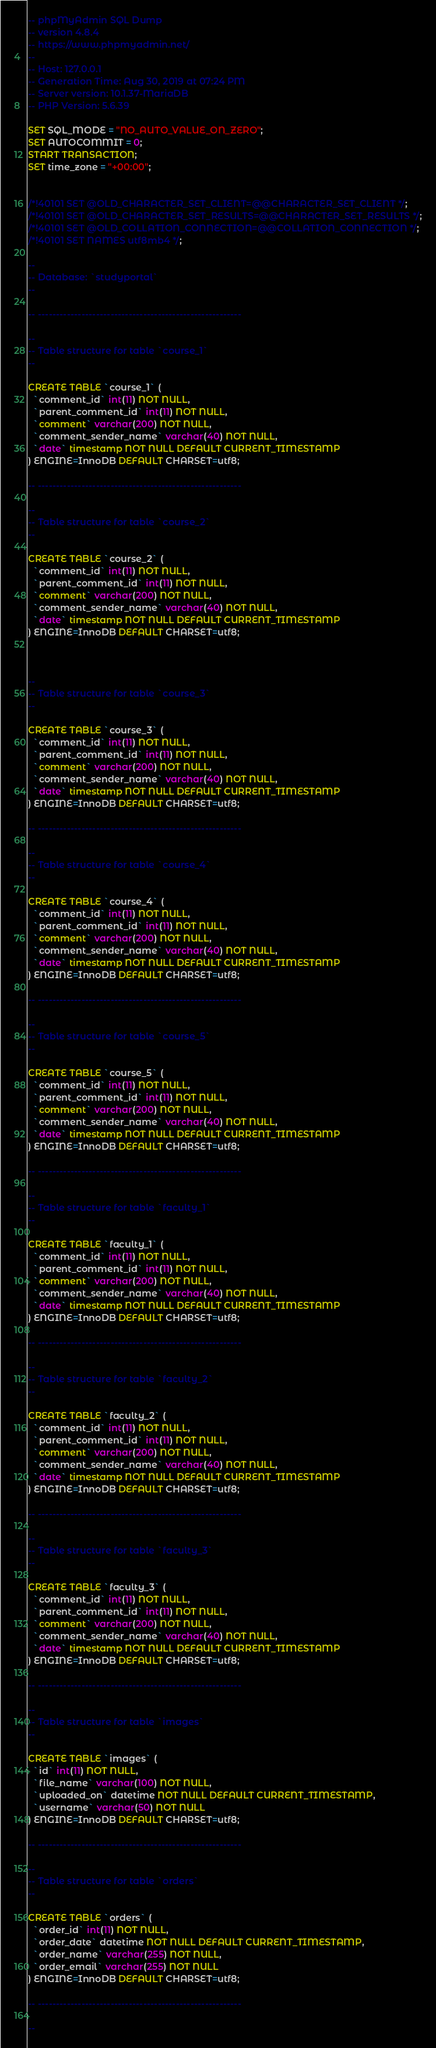Convert code to text. <code><loc_0><loc_0><loc_500><loc_500><_SQL_>-- phpMyAdmin SQL Dump
-- version 4.8.4
-- https://www.phpmyadmin.net/
--
-- Host: 127.0.0.1
-- Generation Time: Aug 30, 2019 at 07:24 PM
-- Server version: 10.1.37-MariaDB
-- PHP Version: 5.6.39

SET SQL_MODE = "NO_AUTO_VALUE_ON_ZERO";
SET AUTOCOMMIT = 0;
START TRANSACTION;
SET time_zone = "+00:00";


/*!40101 SET @OLD_CHARACTER_SET_CLIENT=@@CHARACTER_SET_CLIENT */;
/*!40101 SET @OLD_CHARACTER_SET_RESULTS=@@CHARACTER_SET_RESULTS */;
/*!40101 SET @OLD_COLLATION_CONNECTION=@@COLLATION_CONNECTION */;
/*!40101 SET NAMES utf8mb4 */;

--
-- Database: `studyportal`
--

-- --------------------------------------------------------

--
-- Table structure for table `course_1`
--

CREATE TABLE `course_1` (
  `comment_id` int(11) NOT NULL,
  `parent_comment_id` int(11) NOT NULL,
  `comment` varchar(200) NOT NULL,
  `comment_sender_name` varchar(40) NOT NULL,
  `date` timestamp NOT NULL DEFAULT CURRENT_TIMESTAMP
) ENGINE=InnoDB DEFAULT CHARSET=utf8;

-- --------------------------------------------------------

--
-- Table structure for table `course_2`
--

CREATE TABLE `course_2` (
  `comment_id` int(11) NOT NULL,
  `parent_comment_id` int(11) NOT NULL,
  `comment` varchar(200) NOT NULL,
  `comment_sender_name` varchar(40) NOT NULL,
  `date` timestamp NOT NULL DEFAULT CURRENT_TIMESTAMP
) ENGINE=InnoDB DEFAULT CHARSET=utf8;



--
-- Table structure for table `course_3`
--

CREATE TABLE `course_3` (
  `comment_id` int(11) NOT NULL,
  `parent_comment_id` int(11) NOT NULL,
  `comment` varchar(200) NOT NULL,
  `comment_sender_name` varchar(40) NOT NULL,
  `date` timestamp NOT NULL DEFAULT CURRENT_TIMESTAMP
) ENGINE=InnoDB DEFAULT CHARSET=utf8;

-- --------------------------------------------------------

--
-- Table structure for table `course_4`
--

CREATE TABLE `course_4` (
  `comment_id` int(11) NOT NULL,
  `parent_comment_id` int(11) NOT NULL,
  `comment` varchar(200) NOT NULL,
  `comment_sender_name` varchar(40) NOT NULL,
  `date` timestamp NOT NULL DEFAULT CURRENT_TIMESTAMP
) ENGINE=InnoDB DEFAULT CHARSET=utf8;

-- --------------------------------------------------------

--
-- Table structure for table `course_5`
--

CREATE TABLE `course_5` (
  `comment_id` int(11) NOT NULL,
  `parent_comment_id` int(11) NOT NULL,
  `comment` varchar(200) NOT NULL,
  `comment_sender_name` varchar(40) NOT NULL,
  `date` timestamp NOT NULL DEFAULT CURRENT_TIMESTAMP
) ENGINE=InnoDB DEFAULT CHARSET=utf8;

-- --------------------------------------------------------

--
-- Table structure for table `faculty_1`
--

CREATE TABLE `faculty_1` (
  `comment_id` int(11) NOT NULL,
  `parent_comment_id` int(11) NOT NULL,
  `comment` varchar(200) NOT NULL,
  `comment_sender_name` varchar(40) NOT NULL,
  `date` timestamp NOT NULL DEFAULT CURRENT_TIMESTAMP
) ENGINE=InnoDB DEFAULT CHARSET=utf8;

-- --------------------------------------------------------

--
-- Table structure for table `faculty_2`
--

CREATE TABLE `faculty_2` (
  `comment_id` int(11) NOT NULL,
  `parent_comment_id` int(11) NOT NULL,
  `comment` varchar(200) NOT NULL,
  `comment_sender_name` varchar(40) NOT NULL,
  `date` timestamp NOT NULL DEFAULT CURRENT_TIMESTAMP
) ENGINE=InnoDB DEFAULT CHARSET=utf8;

-- --------------------------------------------------------

--
-- Table structure for table `faculty_3`
--

CREATE TABLE `faculty_3` (
  `comment_id` int(11) NOT NULL,
  `parent_comment_id` int(11) NOT NULL,
  `comment` varchar(200) NOT NULL,
  `comment_sender_name` varchar(40) NOT NULL,
  `date` timestamp NOT NULL DEFAULT CURRENT_TIMESTAMP
) ENGINE=InnoDB DEFAULT CHARSET=utf8;

-- --------------------------------------------------------

--
-- Table structure for table `images`
--

CREATE TABLE `images` (
  `id` int(11) NOT NULL,
  `file_name` varchar(100) NOT NULL,
  `uploaded_on` datetime NOT NULL DEFAULT CURRENT_TIMESTAMP,
  `username` varchar(50) NOT NULL
) ENGINE=InnoDB DEFAULT CHARSET=utf8;

-- --------------------------------------------------------

--
-- Table structure for table `orders`
--

CREATE TABLE `orders` (
  `order_id` int(11) NOT NULL,
  `order_date` datetime NOT NULL DEFAULT CURRENT_TIMESTAMP,
  `order_name` varchar(255) NOT NULL,
  `order_email` varchar(255) NOT NULL
) ENGINE=InnoDB DEFAULT CHARSET=utf8;

-- --------------------------------------------------------

--</code> 